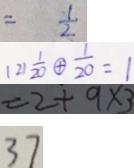Convert formula to latex. <formula><loc_0><loc_0><loc_500><loc_500>= \frac { 1 } { 2 } 
 ( 2 ) \frac { 1 } { 2 0 } \textcircled { + } \frac { 1 } { 2 0 } = 1 
 = 2 + 9 \times 3 
 3 7</formula> 